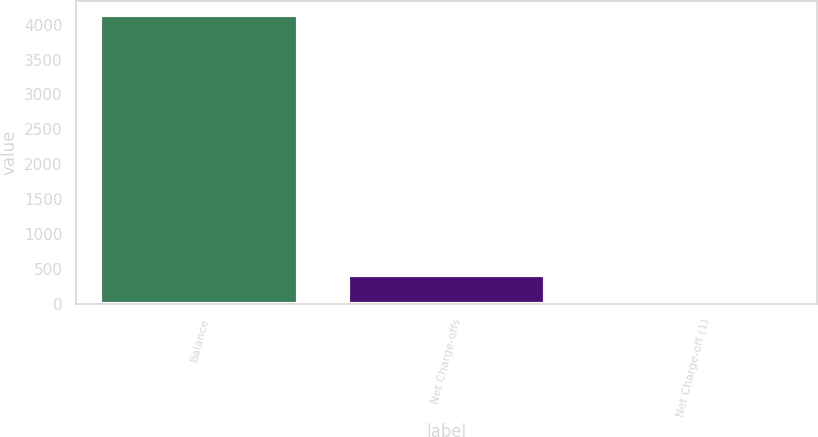Convert chart to OTSL. <chart><loc_0><loc_0><loc_500><loc_500><bar_chart><fcel>Balance<fcel>Net Charge-offs<fcel>Net Charge-off (1)<nl><fcel>4139<fcel>414.62<fcel>0.8<nl></chart> 